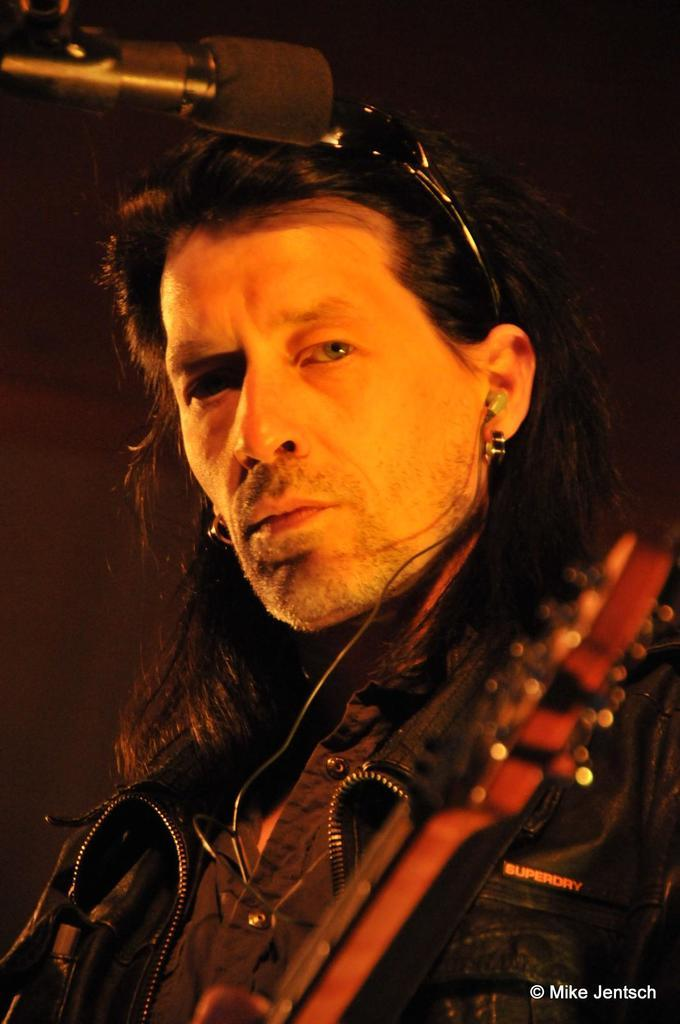Who is the main subject in the image? There is a man in the image. What is the man doing in the image? The man is standing in front of a microphone. Where is the woman standing in the image? There is no woman present in the image. How many trees are visible in the image? There are no trees visible in the image. 